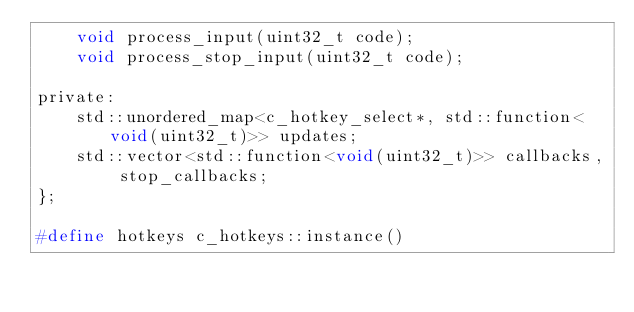Convert code to text. <code><loc_0><loc_0><loc_500><loc_500><_C_>	void process_input(uint32_t code);
	void process_stop_input(uint32_t code);

private:
	std::unordered_map<c_hotkey_select*, std::function<void(uint32_t)>> updates;
	std::vector<std::function<void(uint32_t)>> callbacks, stop_callbacks;
};

#define hotkeys c_hotkeys::instance()
</code> 